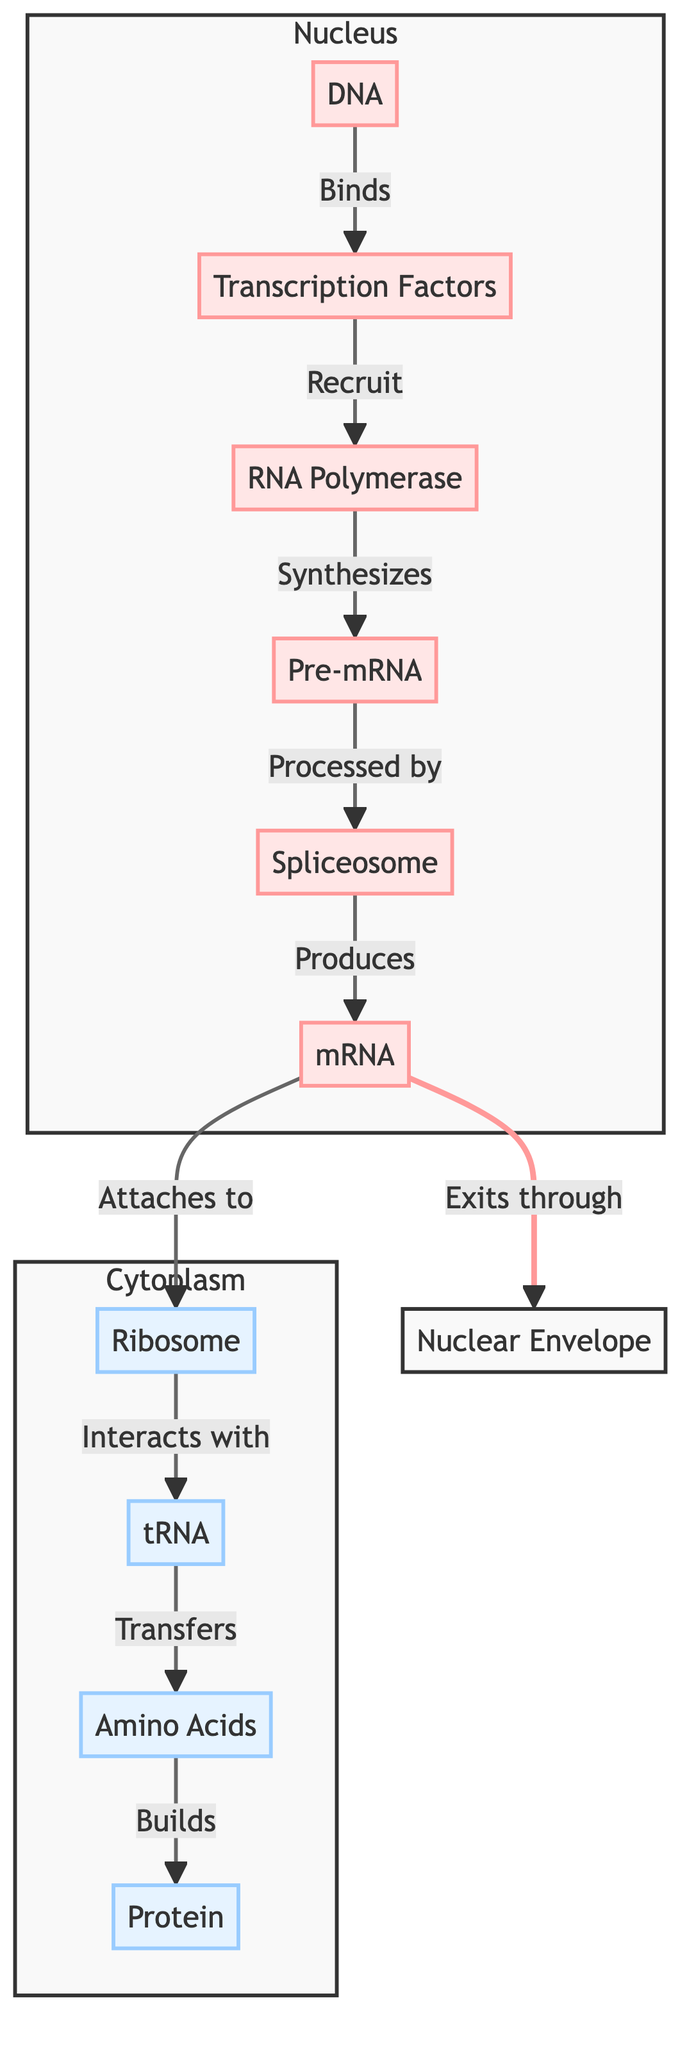What binds to the DNA? According to the diagram, Transcription Factors are indicated to bind to the DNA, creating an interaction where they initiate the process of gene expression.
Answer: Transcription Factors How many nodes are in the nucleus? The nodes present within the Nucleus subgraph are DNA, Transcription Factors, RNA Polymerase, Pre-mRNA, Spliceosome, and mRNA. This totals 6 nodes in the nucleus.
Answer: 6 What role does RNA Polymerase play? RNA Polymerase is shown in the diagram as synthesizing Pre-mRNA after it is recruited by Transcription Factors. This indicates its primary function in gene expression.
Answer: Synthesizes What is produced by the Spliceosome? The diagram indicates that the Spliceosome processes Pre-mRNA and produces mRNA as an output, highlighting its role in mRNA maturation.
Answer: mRNA What do mRNA and Ribosome do together? The diagrams indicate that mRNA attaches to the Ribosome, which is the beginning of the translation process, demonstrating the interaction required for protein synthesis.
Answer: Attaches to What follows the binding of Transcription Factors to DNA? Once Transcription Factors bind to DNA, they recruit RNA Polymerase, which then initiates the synthesis of Pre-mRNA. This sequence illustrates the regulatory action of the transcription factors.
Answer: Recruit RNA Polymerase How does the tRNA contribute to protein synthesis? In the pathway, tRNA transfers Amino Acids to the Ribosome, signifying its crucial role in translating mRNA into a polypeptide chain — a key step in protein synthesis.
Answer: Transfers What is the relationship between mRNA and Nuclear Envelope? The diagram indicates that mRNA exits through the Nuclear Envelope, establishing a connection between the nucleus, where mRNA is synthesized, and the cytoplasm where translation occurs.
Answer: Exits through Which component interacts with tRNA? The diagram shows that the Ribosome interacts with tRNA in the cytoplasm, emphasizing the collaborative interaction necessary for the formation of proteins from the translated sequences.
Answer: Interacts with 